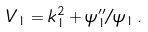<formula> <loc_0><loc_0><loc_500><loc_500>V _ { 1 } = k _ { 1 } ^ { 2 } + \psi _ { 1 } ^ { \prime \prime } / \psi _ { 1 } \, .</formula> 